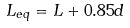Convert formula to latex. <formula><loc_0><loc_0><loc_500><loc_500>L _ { e q } = L + 0 . 8 5 d</formula> 